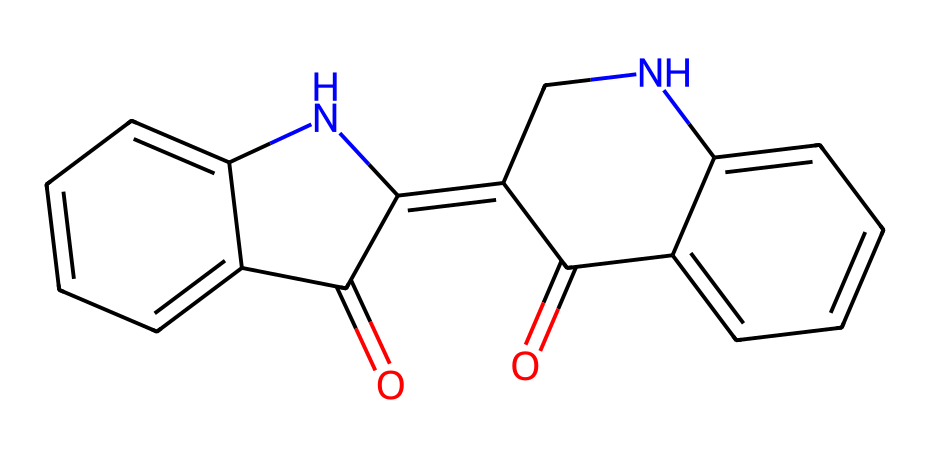What is the name of this dye? The visual structure reveals a common dye known for its deep blue color, primarily used in textiles like denim. This specific dye is indigo.
Answer: indigo How many nitrogen atoms are present in the structure? By analyzing the SMILES representation, we can identify that there are two nitrogen atoms represented in the structure.
Answer: two What functional group is indicated by the "O=C" part of the structure? The "O=C" notation shows a carbonyl group, which is characterized by a carbon atom double-bonded to an oxygen atom. This group is associated with several chemical properties related to dyes.
Answer: carbonyl group Is this dye considered natural or synthetic? Indigo can be derived from natural plant sources or produced synthetically. Given its widespread use, it is often classified as a natural dye.
Answer: natural How many rings are present in the indigo structure? Upon examining the structure, it can be noted that there are three distinct aromatic rings that contribute to the dye's complex structure and characteristics.
Answer: three What type of chemical is this compound categorized as? This compound belongs to the category of organic dyes, specifically synthetic dyes often used in textile applications for coloring fabrics.
Answer: organic dye What property of indigo contributes to its stability in denim? The presence of multiple aromatic rings in the structure contributes to the chemical stability and resistance to fading, a desirable property for a dye used in textiles.
Answer: aromatic rings 